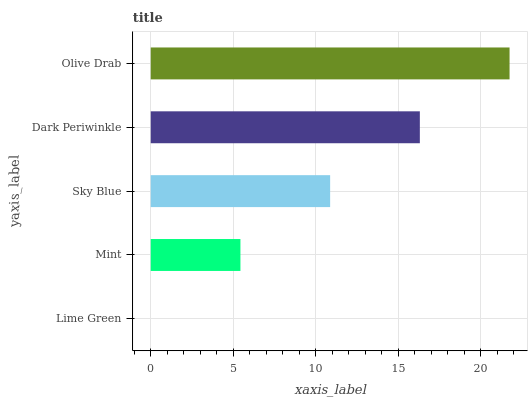Is Lime Green the minimum?
Answer yes or no. Yes. Is Olive Drab the maximum?
Answer yes or no. Yes. Is Mint the minimum?
Answer yes or no. No. Is Mint the maximum?
Answer yes or no. No. Is Mint greater than Lime Green?
Answer yes or no. Yes. Is Lime Green less than Mint?
Answer yes or no. Yes. Is Lime Green greater than Mint?
Answer yes or no. No. Is Mint less than Lime Green?
Answer yes or no. No. Is Sky Blue the high median?
Answer yes or no. Yes. Is Sky Blue the low median?
Answer yes or no. Yes. Is Lime Green the high median?
Answer yes or no. No. Is Lime Green the low median?
Answer yes or no. No. 